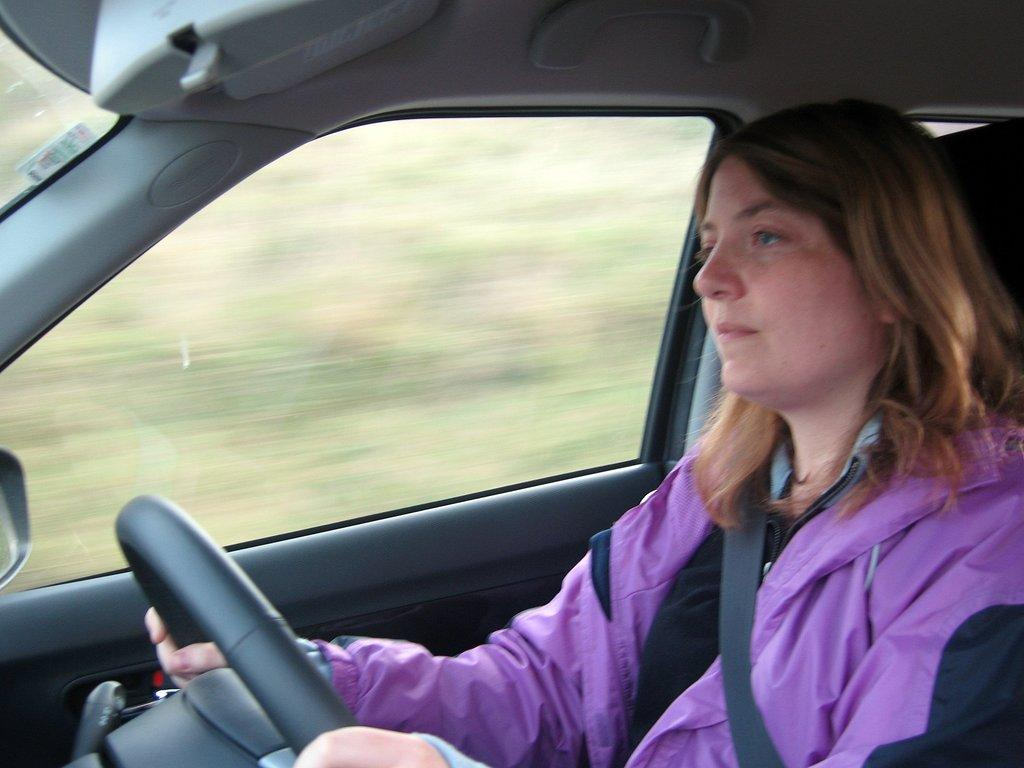What is the woman doing in the image? She is sitting in a car and driving. What safety measure is she taking while driving? She is wearing a car seat belt. What can be seen in the background of the image? There is a car door and a mirror visible in the background. How many rings is she wearing on her hand in the image? There is no information about rings or hands in the image, so we cannot answer that question. 